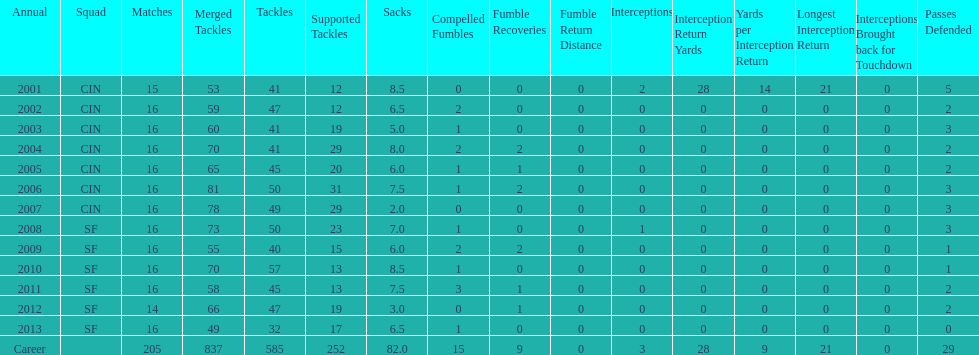How many consecutive seasons has he played sixteen games? 10. 